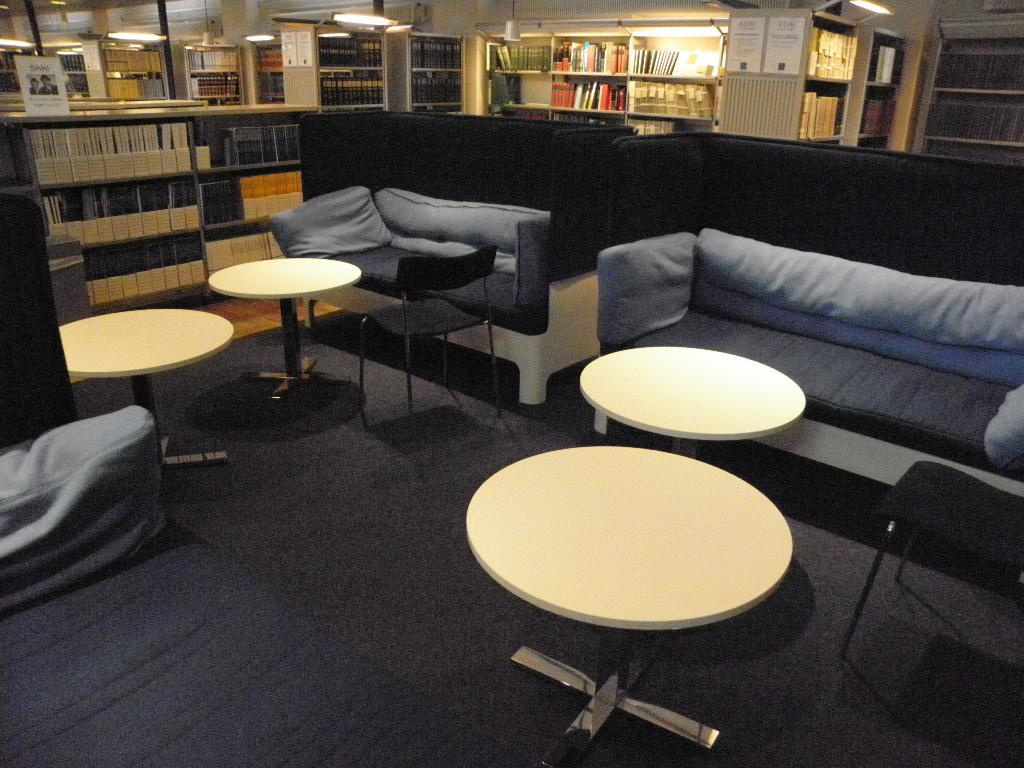What type of room is depicted in the image? There is a living room in the image. What furniture pieces can be seen in the living room? There are many tables and sofas in the living room. Are there any storage units in the living room? Yes, there are shelves in the living room. What type of punishment is being administered in the living room? There is no punishment being administered in the living room; the image only shows furniture and storage units. Can you tell me how many balloons are floating in the living room? There are no balloons present in the living room; the image only shows furniture and storage units. 